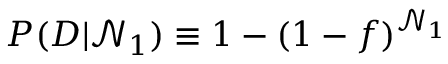<formula> <loc_0><loc_0><loc_500><loc_500>P ( D | \mathcal { N } _ { 1 } ) \equiv 1 - ( 1 - f ) ^ { \mathcal { N } _ { 1 } }</formula> 